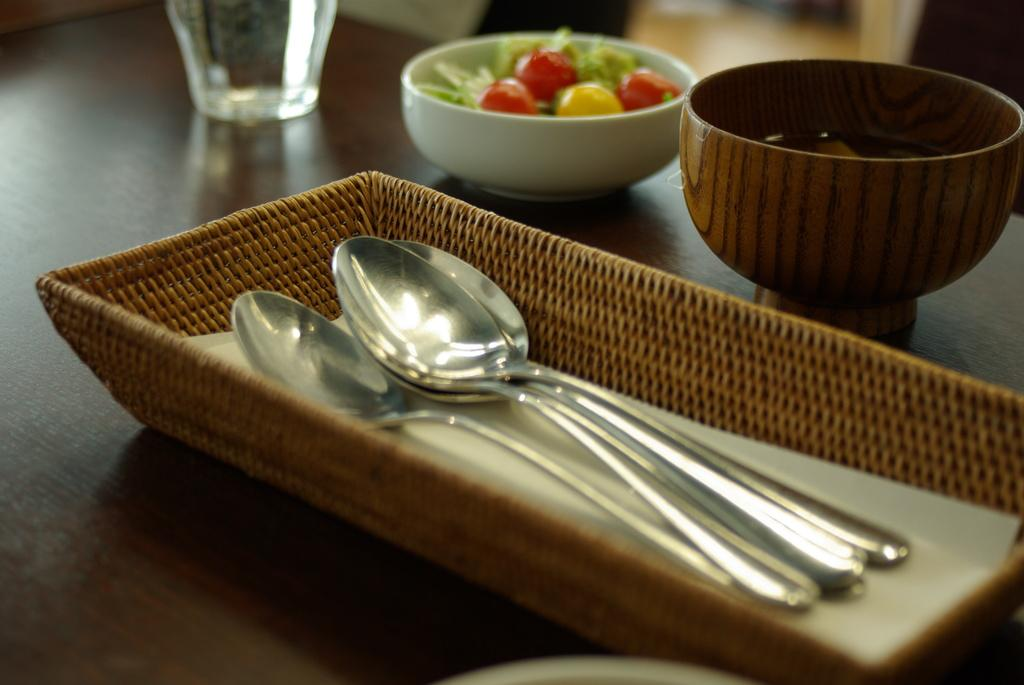What piece of furniture is present in the image? There is a table in the image. What utensils can be seen on the table? There are spoons on the table. What other items are on the table besides spoons? There is a tray, a bowl, a glass, and food placed on the table. What type of pancake is being served on the table in the image? There is no pancake present in the image; it only shows a table with spoons, a tray, a bowl, a glass, and food. 